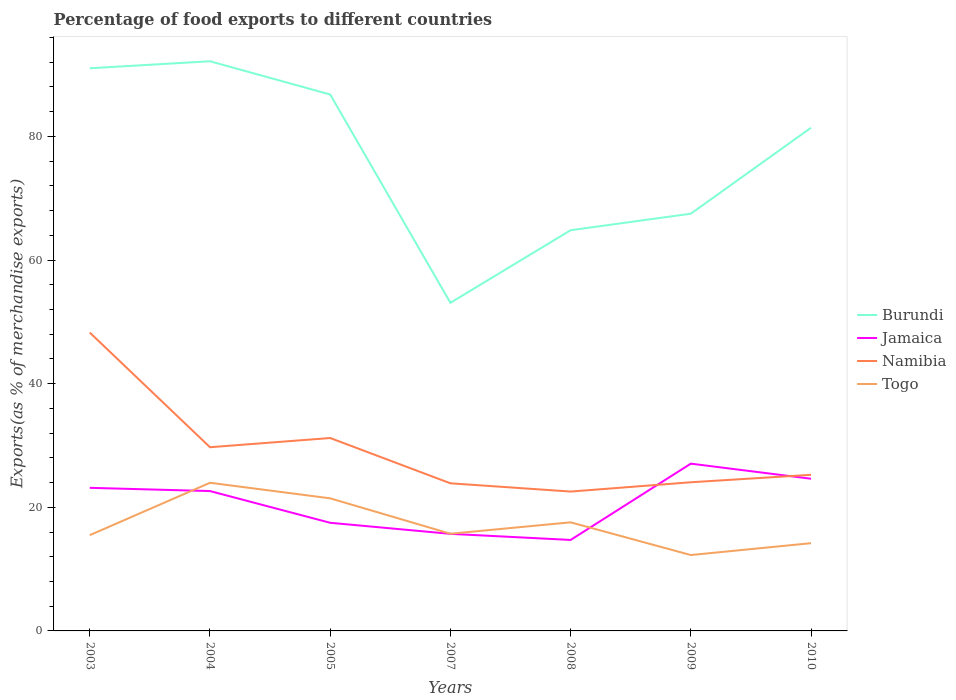How many different coloured lines are there?
Provide a short and direct response. 4. Across all years, what is the maximum percentage of exports to different countries in Namibia?
Offer a very short reply. 22.55. In which year was the percentage of exports to different countries in Togo maximum?
Ensure brevity in your answer.  2009. What is the total percentage of exports to different countries in Jamaica in the graph?
Provide a succinct answer. 5.13. What is the difference between the highest and the second highest percentage of exports to different countries in Jamaica?
Provide a short and direct response. 12.34. Is the percentage of exports to different countries in Jamaica strictly greater than the percentage of exports to different countries in Burundi over the years?
Give a very brief answer. Yes. How many lines are there?
Your response must be concise. 4. How many years are there in the graph?
Keep it short and to the point. 7. Are the values on the major ticks of Y-axis written in scientific E-notation?
Keep it short and to the point. No. Does the graph contain grids?
Offer a terse response. No. What is the title of the graph?
Offer a very short reply. Percentage of food exports to different countries. What is the label or title of the Y-axis?
Your answer should be compact. Exports(as % of merchandise exports). What is the Exports(as % of merchandise exports) in Burundi in 2003?
Make the answer very short. 91.03. What is the Exports(as % of merchandise exports) of Jamaica in 2003?
Your response must be concise. 23.15. What is the Exports(as % of merchandise exports) of Namibia in 2003?
Provide a short and direct response. 48.27. What is the Exports(as % of merchandise exports) of Togo in 2003?
Ensure brevity in your answer.  15.49. What is the Exports(as % of merchandise exports) of Burundi in 2004?
Give a very brief answer. 92.16. What is the Exports(as % of merchandise exports) in Jamaica in 2004?
Provide a short and direct response. 22.63. What is the Exports(as % of merchandise exports) in Namibia in 2004?
Offer a terse response. 29.72. What is the Exports(as % of merchandise exports) in Togo in 2004?
Offer a very short reply. 23.97. What is the Exports(as % of merchandise exports) of Burundi in 2005?
Keep it short and to the point. 86.78. What is the Exports(as % of merchandise exports) in Jamaica in 2005?
Provide a short and direct response. 17.49. What is the Exports(as % of merchandise exports) in Namibia in 2005?
Provide a short and direct response. 31.21. What is the Exports(as % of merchandise exports) in Togo in 2005?
Ensure brevity in your answer.  21.45. What is the Exports(as % of merchandise exports) in Burundi in 2007?
Your answer should be very brief. 53.08. What is the Exports(as % of merchandise exports) in Jamaica in 2007?
Provide a succinct answer. 15.7. What is the Exports(as % of merchandise exports) of Namibia in 2007?
Offer a very short reply. 23.88. What is the Exports(as % of merchandise exports) in Togo in 2007?
Offer a terse response. 15.72. What is the Exports(as % of merchandise exports) of Burundi in 2008?
Offer a very short reply. 64.83. What is the Exports(as % of merchandise exports) of Jamaica in 2008?
Provide a short and direct response. 14.72. What is the Exports(as % of merchandise exports) in Namibia in 2008?
Your answer should be very brief. 22.55. What is the Exports(as % of merchandise exports) of Togo in 2008?
Provide a succinct answer. 17.57. What is the Exports(as % of merchandise exports) of Burundi in 2009?
Your answer should be very brief. 67.5. What is the Exports(as % of merchandise exports) of Jamaica in 2009?
Ensure brevity in your answer.  27.06. What is the Exports(as % of merchandise exports) in Namibia in 2009?
Your answer should be compact. 24.05. What is the Exports(as % of merchandise exports) in Togo in 2009?
Make the answer very short. 12.28. What is the Exports(as % of merchandise exports) of Burundi in 2010?
Provide a succinct answer. 81.41. What is the Exports(as % of merchandise exports) of Jamaica in 2010?
Your answer should be compact. 24.62. What is the Exports(as % of merchandise exports) of Namibia in 2010?
Ensure brevity in your answer.  25.25. What is the Exports(as % of merchandise exports) in Togo in 2010?
Give a very brief answer. 14.2. Across all years, what is the maximum Exports(as % of merchandise exports) in Burundi?
Your answer should be compact. 92.16. Across all years, what is the maximum Exports(as % of merchandise exports) in Jamaica?
Give a very brief answer. 27.06. Across all years, what is the maximum Exports(as % of merchandise exports) in Namibia?
Make the answer very short. 48.27. Across all years, what is the maximum Exports(as % of merchandise exports) of Togo?
Give a very brief answer. 23.97. Across all years, what is the minimum Exports(as % of merchandise exports) in Burundi?
Offer a terse response. 53.08. Across all years, what is the minimum Exports(as % of merchandise exports) in Jamaica?
Offer a terse response. 14.72. Across all years, what is the minimum Exports(as % of merchandise exports) of Namibia?
Ensure brevity in your answer.  22.55. Across all years, what is the minimum Exports(as % of merchandise exports) in Togo?
Keep it short and to the point. 12.28. What is the total Exports(as % of merchandise exports) of Burundi in the graph?
Make the answer very short. 536.78. What is the total Exports(as % of merchandise exports) of Jamaica in the graph?
Keep it short and to the point. 145.37. What is the total Exports(as % of merchandise exports) in Namibia in the graph?
Give a very brief answer. 204.93. What is the total Exports(as % of merchandise exports) in Togo in the graph?
Your answer should be compact. 120.68. What is the difference between the Exports(as % of merchandise exports) in Burundi in 2003 and that in 2004?
Offer a terse response. -1.13. What is the difference between the Exports(as % of merchandise exports) in Jamaica in 2003 and that in 2004?
Make the answer very short. 0.52. What is the difference between the Exports(as % of merchandise exports) in Namibia in 2003 and that in 2004?
Offer a very short reply. 18.55. What is the difference between the Exports(as % of merchandise exports) of Togo in 2003 and that in 2004?
Offer a terse response. -8.47. What is the difference between the Exports(as % of merchandise exports) in Burundi in 2003 and that in 2005?
Offer a terse response. 4.24. What is the difference between the Exports(as % of merchandise exports) of Jamaica in 2003 and that in 2005?
Your answer should be compact. 5.66. What is the difference between the Exports(as % of merchandise exports) in Namibia in 2003 and that in 2005?
Ensure brevity in your answer.  17.06. What is the difference between the Exports(as % of merchandise exports) of Togo in 2003 and that in 2005?
Keep it short and to the point. -5.96. What is the difference between the Exports(as % of merchandise exports) of Burundi in 2003 and that in 2007?
Offer a terse response. 37.94. What is the difference between the Exports(as % of merchandise exports) in Jamaica in 2003 and that in 2007?
Your answer should be compact. 7.44. What is the difference between the Exports(as % of merchandise exports) in Namibia in 2003 and that in 2007?
Your answer should be very brief. 24.38. What is the difference between the Exports(as % of merchandise exports) of Togo in 2003 and that in 2007?
Provide a succinct answer. -0.23. What is the difference between the Exports(as % of merchandise exports) in Burundi in 2003 and that in 2008?
Your answer should be compact. 26.2. What is the difference between the Exports(as % of merchandise exports) in Jamaica in 2003 and that in 2008?
Your answer should be very brief. 8.43. What is the difference between the Exports(as % of merchandise exports) in Namibia in 2003 and that in 2008?
Your answer should be compact. 25.72. What is the difference between the Exports(as % of merchandise exports) of Togo in 2003 and that in 2008?
Make the answer very short. -2.07. What is the difference between the Exports(as % of merchandise exports) of Burundi in 2003 and that in 2009?
Offer a terse response. 23.53. What is the difference between the Exports(as % of merchandise exports) of Jamaica in 2003 and that in 2009?
Give a very brief answer. -3.91. What is the difference between the Exports(as % of merchandise exports) in Namibia in 2003 and that in 2009?
Offer a terse response. 24.22. What is the difference between the Exports(as % of merchandise exports) in Togo in 2003 and that in 2009?
Provide a short and direct response. 3.22. What is the difference between the Exports(as % of merchandise exports) in Burundi in 2003 and that in 2010?
Your answer should be compact. 9.62. What is the difference between the Exports(as % of merchandise exports) in Jamaica in 2003 and that in 2010?
Your answer should be compact. -1.47. What is the difference between the Exports(as % of merchandise exports) in Namibia in 2003 and that in 2010?
Make the answer very short. 23.01. What is the difference between the Exports(as % of merchandise exports) in Togo in 2003 and that in 2010?
Offer a terse response. 1.3. What is the difference between the Exports(as % of merchandise exports) of Burundi in 2004 and that in 2005?
Keep it short and to the point. 5.38. What is the difference between the Exports(as % of merchandise exports) in Jamaica in 2004 and that in 2005?
Your response must be concise. 5.13. What is the difference between the Exports(as % of merchandise exports) in Namibia in 2004 and that in 2005?
Provide a short and direct response. -1.49. What is the difference between the Exports(as % of merchandise exports) in Togo in 2004 and that in 2005?
Offer a very short reply. 2.52. What is the difference between the Exports(as % of merchandise exports) of Burundi in 2004 and that in 2007?
Offer a terse response. 39.08. What is the difference between the Exports(as % of merchandise exports) in Jamaica in 2004 and that in 2007?
Make the answer very short. 6.92. What is the difference between the Exports(as % of merchandise exports) in Namibia in 2004 and that in 2007?
Provide a short and direct response. 5.84. What is the difference between the Exports(as % of merchandise exports) in Togo in 2004 and that in 2007?
Your answer should be compact. 8.25. What is the difference between the Exports(as % of merchandise exports) in Burundi in 2004 and that in 2008?
Provide a succinct answer. 27.33. What is the difference between the Exports(as % of merchandise exports) in Jamaica in 2004 and that in 2008?
Your answer should be very brief. 7.91. What is the difference between the Exports(as % of merchandise exports) of Namibia in 2004 and that in 2008?
Offer a very short reply. 7.17. What is the difference between the Exports(as % of merchandise exports) of Togo in 2004 and that in 2008?
Provide a succinct answer. 6.4. What is the difference between the Exports(as % of merchandise exports) in Burundi in 2004 and that in 2009?
Offer a very short reply. 24.66. What is the difference between the Exports(as % of merchandise exports) in Jamaica in 2004 and that in 2009?
Provide a succinct answer. -4.44. What is the difference between the Exports(as % of merchandise exports) in Namibia in 2004 and that in 2009?
Offer a terse response. 5.67. What is the difference between the Exports(as % of merchandise exports) of Togo in 2004 and that in 2009?
Give a very brief answer. 11.69. What is the difference between the Exports(as % of merchandise exports) in Burundi in 2004 and that in 2010?
Your answer should be compact. 10.75. What is the difference between the Exports(as % of merchandise exports) in Jamaica in 2004 and that in 2010?
Offer a terse response. -1.99. What is the difference between the Exports(as % of merchandise exports) in Namibia in 2004 and that in 2010?
Keep it short and to the point. 4.46. What is the difference between the Exports(as % of merchandise exports) of Togo in 2004 and that in 2010?
Your answer should be compact. 9.77. What is the difference between the Exports(as % of merchandise exports) of Burundi in 2005 and that in 2007?
Give a very brief answer. 33.7. What is the difference between the Exports(as % of merchandise exports) of Jamaica in 2005 and that in 2007?
Offer a terse response. 1.79. What is the difference between the Exports(as % of merchandise exports) in Namibia in 2005 and that in 2007?
Offer a very short reply. 7.33. What is the difference between the Exports(as % of merchandise exports) in Togo in 2005 and that in 2007?
Offer a very short reply. 5.73. What is the difference between the Exports(as % of merchandise exports) of Burundi in 2005 and that in 2008?
Offer a terse response. 21.96. What is the difference between the Exports(as % of merchandise exports) in Jamaica in 2005 and that in 2008?
Your answer should be compact. 2.78. What is the difference between the Exports(as % of merchandise exports) of Namibia in 2005 and that in 2008?
Provide a succinct answer. 8.66. What is the difference between the Exports(as % of merchandise exports) in Togo in 2005 and that in 2008?
Give a very brief answer. 3.88. What is the difference between the Exports(as % of merchandise exports) of Burundi in 2005 and that in 2009?
Give a very brief answer. 19.28. What is the difference between the Exports(as % of merchandise exports) of Jamaica in 2005 and that in 2009?
Offer a very short reply. -9.57. What is the difference between the Exports(as % of merchandise exports) in Namibia in 2005 and that in 2009?
Keep it short and to the point. 7.16. What is the difference between the Exports(as % of merchandise exports) in Togo in 2005 and that in 2009?
Keep it short and to the point. 9.17. What is the difference between the Exports(as % of merchandise exports) of Burundi in 2005 and that in 2010?
Give a very brief answer. 5.38. What is the difference between the Exports(as % of merchandise exports) in Jamaica in 2005 and that in 2010?
Keep it short and to the point. -7.12. What is the difference between the Exports(as % of merchandise exports) in Namibia in 2005 and that in 2010?
Ensure brevity in your answer.  5.95. What is the difference between the Exports(as % of merchandise exports) of Togo in 2005 and that in 2010?
Ensure brevity in your answer.  7.25. What is the difference between the Exports(as % of merchandise exports) of Burundi in 2007 and that in 2008?
Give a very brief answer. -11.74. What is the difference between the Exports(as % of merchandise exports) of Jamaica in 2007 and that in 2008?
Provide a short and direct response. 0.99. What is the difference between the Exports(as % of merchandise exports) of Namibia in 2007 and that in 2008?
Ensure brevity in your answer.  1.34. What is the difference between the Exports(as % of merchandise exports) of Togo in 2007 and that in 2008?
Your answer should be very brief. -1.84. What is the difference between the Exports(as % of merchandise exports) in Burundi in 2007 and that in 2009?
Provide a succinct answer. -14.41. What is the difference between the Exports(as % of merchandise exports) in Jamaica in 2007 and that in 2009?
Your answer should be very brief. -11.36. What is the difference between the Exports(as % of merchandise exports) in Namibia in 2007 and that in 2009?
Your response must be concise. -0.17. What is the difference between the Exports(as % of merchandise exports) of Togo in 2007 and that in 2009?
Offer a terse response. 3.45. What is the difference between the Exports(as % of merchandise exports) of Burundi in 2007 and that in 2010?
Make the answer very short. -28.32. What is the difference between the Exports(as % of merchandise exports) in Jamaica in 2007 and that in 2010?
Offer a very short reply. -8.91. What is the difference between the Exports(as % of merchandise exports) of Namibia in 2007 and that in 2010?
Provide a succinct answer. -1.37. What is the difference between the Exports(as % of merchandise exports) in Togo in 2007 and that in 2010?
Your answer should be compact. 1.53. What is the difference between the Exports(as % of merchandise exports) in Burundi in 2008 and that in 2009?
Offer a very short reply. -2.67. What is the difference between the Exports(as % of merchandise exports) of Jamaica in 2008 and that in 2009?
Make the answer very short. -12.34. What is the difference between the Exports(as % of merchandise exports) of Namibia in 2008 and that in 2009?
Give a very brief answer. -1.5. What is the difference between the Exports(as % of merchandise exports) of Togo in 2008 and that in 2009?
Ensure brevity in your answer.  5.29. What is the difference between the Exports(as % of merchandise exports) in Burundi in 2008 and that in 2010?
Ensure brevity in your answer.  -16.58. What is the difference between the Exports(as % of merchandise exports) of Jamaica in 2008 and that in 2010?
Your answer should be very brief. -9.9. What is the difference between the Exports(as % of merchandise exports) in Namibia in 2008 and that in 2010?
Give a very brief answer. -2.71. What is the difference between the Exports(as % of merchandise exports) of Togo in 2008 and that in 2010?
Make the answer very short. 3.37. What is the difference between the Exports(as % of merchandise exports) in Burundi in 2009 and that in 2010?
Your answer should be very brief. -13.91. What is the difference between the Exports(as % of merchandise exports) of Jamaica in 2009 and that in 2010?
Your answer should be very brief. 2.44. What is the difference between the Exports(as % of merchandise exports) in Namibia in 2009 and that in 2010?
Your answer should be very brief. -1.2. What is the difference between the Exports(as % of merchandise exports) in Togo in 2009 and that in 2010?
Offer a terse response. -1.92. What is the difference between the Exports(as % of merchandise exports) in Burundi in 2003 and the Exports(as % of merchandise exports) in Jamaica in 2004?
Give a very brief answer. 68.4. What is the difference between the Exports(as % of merchandise exports) in Burundi in 2003 and the Exports(as % of merchandise exports) in Namibia in 2004?
Make the answer very short. 61.31. What is the difference between the Exports(as % of merchandise exports) of Burundi in 2003 and the Exports(as % of merchandise exports) of Togo in 2004?
Ensure brevity in your answer.  67.06. What is the difference between the Exports(as % of merchandise exports) of Jamaica in 2003 and the Exports(as % of merchandise exports) of Namibia in 2004?
Provide a succinct answer. -6.57. What is the difference between the Exports(as % of merchandise exports) of Jamaica in 2003 and the Exports(as % of merchandise exports) of Togo in 2004?
Ensure brevity in your answer.  -0.82. What is the difference between the Exports(as % of merchandise exports) of Namibia in 2003 and the Exports(as % of merchandise exports) of Togo in 2004?
Your answer should be compact. 24.3. What is the difference between the Exports(as % of merchandise exports) of Burundi in 2003 and the Exports(as % of merchandise exports) of Jamaica in 2005?
Your answer should be compact. 73.53. What is the difference between the Exports(as % of merchandise exports) of Burundi in 2003 and the Exports(as % of merchandise exports) of Namibia in 2005?
Your answer should be compact. 59.82. What is the difference between the Exports(as % of merchandise exports) of Burundi in 2003 and the Exports(as % of merchandise exports) of Togo in 2005?
Provide a succinct answer. 69.58. What is the difference between the Exports(as % of merchandise exports) of Jamaica in 2003 and the Exports(as % of merchandise exports) of Namibia in 2005?
Keep it short and to the point. -8.06. What is the difference between the Exports(as % of merchandise exports) of Jamaica in 2003 and the Exports(as % of merchandise exports) of Togo in 2005?
Offer a very short reply. 1.7. What is the difference between the Exports(as % of merchandise exports) of Namibia in 2003 and the Exports(as % of merchandise exports) of Togo in 2005?
Your response must be concise. 26.82. What is the difference between the Exports(as % of merchandise exports) in Burundi in 2003 and the Exports(as % of merchandise exports) in Jamaica in 2007?
Provide a short and direct response. 75.32. What is the difference between the Exports(as % of merchandise exports) in Burundi in 2003 and the Exports(as % of merchandise exports) in Namibia in 2007?
Your response must be concise. 67.14. What is the difference between the Exports(as % of merchandise exports) of Burundi in 2003 and the Exports(as % of merchandise exports) of Togo in 2007?
Keep it short and to the point. 75.3. What is the difference between the Exports(as % of merchandise exports) in Jamaica in 2003 and the Exports(as % of merchandise exports) in Namibia in 2007?
Offer a terse response. -0.73. What is the difference between the Exports(as % of merchandise exports) of Jamaica in 2003 and the Exports(as % of merchandise exports) of Togo in 2007?
Your answer should be very brief. 7.43. What is the difference between the Exports(as % of merchandise exports) of Namibia in 2003 and the Exports(as % of merchandise exports) of Togo in 2007?
Offer a very short reply. 32.54. What is the difference between the Exports(as % of merchandise exports) in Burundi in 2003 and the Exports(as % of merchandise exports) in Jamaica in 2008?
Provide a short and direct response. 76.31. What is the difference between the Exports(as % of merchandise exports) in Burundi in 2003 and the Exports(as % of merchandise exports) in Namibia in 2008?
Provide a succinct answer. 68.48. What is the difference between the Exports(as % of merchandise exports) in Burundi in 2003 and the Exports(as % of merchandise exports) in Togo in 2008?
Your answer should be very brief. 73.46. What is the difference between the Exports(as % of merchandise exports) of Jamaica in 2003 and the Exports(as % of merchandise exports) of Namibia in 2008?
Your answer should be very brief. 0.6. What is the difference between the Exports(as % of merchandise exports) of Jamaica in 2003 and the Exports(as % of merchandise exports) of Togo in 2008?
Keep it short and to the point. 5.58. What is the difference between the Exports(as % of merchandise exports) of Namibia in 2003 and the Exports(as % of merchandise exports) of Togo in 2008?
Make the answer very short. 30.7. What is the difference between the Exports(as % of merchandise exports) in Burundi in 2003 and the Exports(as % of merchandise exports) in Jamaica in 2009?
Your answer should be very brief. 63.96. What is the difference between the Exports(as % of merchandise exports) in Burundi in 2003 and the Exports(as % of merchandise exports) in Namibia in 2009?
Give a very brief answer. 66.98. What is the difference between the Exports(as % of merchandise exports) of Burundi in 2003 and the Exports(as % of merchandise exports) of Togo in 2009?
Make the answer very short. 78.75. What is the difference between the Exports(as % of merchandise exports) of Jamaica in 2003 and the Exports(as % of merchandise exports) of Namibia in 2009?
Your response must be concise. -0.9. What is the difference between the Exports(as % of merchandise exports) of Jamaica in 2003 and the Exports(as % of merchandise exports) of Togo in 2009?
Your answer should be compact. 10.87. What is the difference between the Exports(as % of merchandise exports) of Namibia in 2003 and the Exports(as % of merchandise exports) of Togo in 2009?
Your response must be concise. 35.99. What is the difference between the Exports(as % of merchandise exports) in Burundi in 2003 and the Exports(as % of merchandise exports) in Jamaica in 2010?
Ensure brevity in your answer.  66.41. What is the difference between the Exports(as % of merchandise exports) of Burundi in 2003 and the Exports(as % of merchandise exports) of Namibia in 2010?
Your answer should be very brief. 65.77. What is the difference between the Exports(as % of merchandise exports) of Burundi in 2003 and the Exports(as % of merchandise exports) of Togo in 2010?
Give a very brief answer. 76.83. What is the difference between the Exports(as % of merchandise exports) in Jamaica in 2003 and the Exports(as % of merchandise exports) in Namibia in 2010?
Give a very brief answer. -2.11. What is the difference between the Exports(as % of merchandise exports) of Jamaica in 2003 and the Exports(as % of merchandise exports) of Togo in 2010?
Your answer should be compact. 8.95. What is the difference between the Exports(as % of merchandise exports) in Namibia in 2003 and the Exports(as % of merchandise exports) in Togo in 2010?
Ensure brevity in your answer.  34.07. What is the difference between the Exports(as % of merchandise exports) of Burundi in 2004 and the Exports(as % of merchandise exports) of Jamaica in 2005?
Offer a very short reply. 74.67. What is the difference between the Exports(as % of merchandise exports) in Burundi in 2004 and the Exports(as % of merchandise exports) in Namibia in 2005?
Keep it short and to the point. 60.95. What is the difference between the Exports(as % of merchandise exports) in Burundi in 2004 and the Exports(as % of merchandise exports) in Togo in 2005?
Ensure brevity in your answer.  70.71. What is the difference between the Exports(as % of merchandise exports) of Jamaica in 2004 and the Exports(as % of merchandise exports) of Namibia in 2005?
Your answer should be compact. -8.58. What is the difference between the Exports(as % of merchandise exports) of Jamaica in 2004 and the Exports(as % of merchandise exports) of Togo in 2005?
Offer a terse response. 1.18. What is the difference between the Exports(as % of merchandise exports) in Namibia in 2004 and the Exports(as % of merchandise exports) in Togo in 2005?
Keep it short and to the point. 8.27. What is the difference between the Exports(as % of merchandise exports) in Burundi in 2004 and the Exports(as % of merchandise exports) in Jamaica in 2007?
Your response must be concise. 76.45. What is the difference between the Exports(as % of merchandise exports) in Burundi in 2004 and the Exports(as % of merchandise exports) in Namibia in 2007?
Ensure brevity in your answer.  68.28. What is the difference between the Exports(as % of merchandise exports) in Burundi in 2004 and the Exports(as % of merchandise exports) in Togo in 2007?
Provide a succinct answer. 76.44. What is the difference between the Exports(as % of merchandise exports) of Jamaica in 2004 and the Exports(as % of merchandise exports) of Namibia in 2007?
Your answer should be compact. -1.26. What is the difference between the Exports(as % of merchandise exports) of Jamaica in 2004 and the Exports(as % of merchandise exports) of Togo in 2007?
Offer a terse response. 6.9. What is the difference between the Exports(as % of merchandise exports) in Namibia in 2004 and the Exports(as % of merchandise exports) in Togo in 2007?
Keep it short and to the point. 14. What is the difference between the Exports(as % of merchandise exports) of Burundi in 2004 and the Exports(as % of merchandise exports) of Jamaica in 2008?
Give a very brief answer. 77.44. What is the difference between the Exports(as % of merchandise exports) in Burundi in 2004 and the Exports(as % of merchandise exports) in Namibia in 2008?
Provide a succinct answer. 69.61. What is the difference between the Exports(as % of merchandise exports) of Burundi in 2004 and the Exports(as % of merchandise exports) of Togo in 2008?
Your answer should be very brief. 74.59. What is the difference between the Exports(as % of merchandise exports) in Jamaica in 2004 and the Exports(as % of merchandise exports) in Namibia in 2008?
Your answer should be very brief. 0.08. What is the difference between the Exports(as % of merchandise exports) in Jamaica in 2004 and the Exports(as % of merchandise exports) in Togo in 2008?
Make the answer very short. 5.06. What is the difference between the Exports(as % of merchandise exports) in Namibia in 2004 and the Exports(as % of merchandise exports) in Togo in 2008?
Provide a short and direct response. 12.15. What is the difference between the Exports(as % of merchandise exports) of Burundi in 2004 and the Exports(as % of merchandise exports) of Jamaica in 2009?
Give a very brief answer. 65.1. What is the difference between the Exports(as % of merchandise exports) of Burundi in 2004 and the Exports(as % of merchandise exports) of Namibia in 2009?
Offer a very short reply. 68.11. What is the difference between the Exports(as % of merchandise exports) of Burundi in 2004 and the Exports(as % of merchandise exports) of Togo in 2009?
Your answer should be very brief. 79.88. What is the difference between the Exports(as % of merchandise exports) of Jamaica in 2004 and the Exports(as % of merchandise exports) of Namibia in 2009?
Give a very brief answer. -1.42. What is the difference between the Exports(as % of merchandise exports) of Jamaica in 2004 and the Exports(as % of merchandise exports) of Togo in 2009?
Your answer should be very brief. 10.35. What is the difference between the Exports(as % of merchandise exports) of Namibia in 2004 and the Exports(as % of merchandise exports) of Togo in 2009?
Provide a succinct answer. 17.44. What is the difference between the Exports(as % of merchandise exports) of Burundi in 2004 and the Exports(as % of merchandise exports) of Jamaica in 2010?
Your answer should be compact. 67.54. What is the difference between the Exports(as % of merchandise exports) in Burundi in 2004 and the Exports(as % of merchandise exports) in Namibia in 2010?
Make the answer very short. 66.91. What is the difference between the Exports(as % of merchandise exports) of Burundi in 2004 and the Exports(as % of merchandise exports) of Togo in 2010?
Your answer should be very brief. 77.96. What is the difference between the Exports(as % of merchandise exports) in Jamaica in 2004 and the Exports(as % of merchandise exports) in Namibia in 2010?
Offer a very short reply. -2.63. What is the difference between the Exports(as % of merchandise exports) of Jamaica in 2004 and the Exports(as % of merchandise exports) of Togo in 2010?
Your answer should be compact. 8.43. What is the difference between the Exports(as % of merchandise exports) of Namibia in 2004 and the Exports(as % of merchandise exports) of Togo in 2010?
Keep it short and to the point. 15.52. What is the difference between the Exports(as % of merchandise exports) of Burundi in 2005 and the Exports(as % of merchandise exports) of Jamaica in 2007?
Offer a terse response. 71.08. What is the difference between the Exports(as % of merchandise exports) of Burundi in 2005 and the Exports(as % of merchandise exports) of Namibia in 2007?
Keep it short and to the point. 62.9. What is the difference between the Exports(as % of merchandise exports) in Burundi in 2005 and the Exports(as % of merchandise exports) in Togo in 2007?
Offer a very short reply. 71.06. What is the difference between the Exports(as % of merchandise exports) of Jamaica in 2005 and the Exports(as % of merchandise exports) of Namibia in 2007?
Your answer should be compact. -6.39. What is the difference between the Exports(as % of merchandise exports) in Jamaica in 2005 and the Exports(as % of merchandise exports) in Togo in 2007?
Your answer should be very brief. 1.77. What is the difference between the Exports(as % of merchandise exports) of Namibia in 2005 and the Exports(as % of merchandise exports) of Togo in 2007?
Make the answer very short. 15.49. What is the difference between the Exports(as % of merchandise exports) of Burundi in 2005 and the Exports(as % of merchandise exports) of Jamaica in 2008?
Your response must be concise. 72.06. What is the difference between the Exports(as % of merchandise exports) of Burundi in 2005 and the Exports(as % of merchandise exports) of Namibia in 2008?
Make the answer very short. 64.24. What is the difference between the Exports(as % of merchandise exports) of Burundi in 2005 and the Exports(as % of merchandise exports) of Togo in 2008?
Your answer should be compact. 69.21. What is the difference between the Exports(as % of merchandise exports) in Jamaica in 2005 and the Exports(as % of merchandise exports) in Namibia in 2008?
Your response must be concise. -5.05. What is the difference between the Exports(as % of merchandise exports) of Jamaica in 2005 and the Exports(as % of merchandise exports) of Togo in 2008?
Your response must be concise. -0.07. What is the difference between the Exports(as % of merchandise exports) in Namibia in 2005 and the Exports(as % of merchandise exports) in Togo in 2008?
Your answer should be very brief. 13.64. What is the difference between the Exports(as % of merchandise exports) in Burundi in 2005 and the Exports(as % of merchandise exports) in Jamaica in 2009?
Make the answer very short. 59.72. What is the difference between the Exports(as % of merchandise exports) in Burundi in 2005 and the Exports(as % of merchandise exports) in Namibia in 2009?
Your response must be concise. 62.73. What is the difference between the Exports(as % of merchandise exports) in Burundi in 2005 and the Exports(as % of merchandise exports) in Togo in 2009?
Your answer should be very brief. 74.51. What is the difference between the Exports(as % of merchandise exports) in Jamaica in 2005 and the Exports(as % of merchandise exports) in Namibia in 2009?
Keep it short and to the point. -6.56. What is the difference between the Exports(as % of merchandise exports) in Jamaica in 2005 and the Exports(as % of merchandise exports) in Togo in 2009?
Your answer should be compact. 5.22. What is the difference between the Exports(as % of merchandise exports) in Namibia in 2005 and the Exports(as % of merchandise exports) in Togo in 2009?
Provide a short and direct response. 18.93. What is the difference between the Exports(as % of merchandise exports) of Burundi in 2005 and the Exports(as % of merchandise exports) of Jamaica in 2010?
Keep it short and to the point. 62.16. What is the difference between the Exports(as % of merchandise exports) of Burundi in 2005 and the Exports(as % of merchandise exports) of Namibia in 2010?
Provide a succinct answer. 61.53. What is the difference between the Exports(as % of merchandise exports) in Burundi in 2005 and the Exports(as % of merchandise exports) in Togo in 2010?
Provide a succinct answer. 72.59. What is the difference between the Exports(as % of merchandise exports) in Jamaica in 2005 and the Exports(as % of merchandise exports) in Namibia in 2010?
Make the answer very short. -7.76. What is the difference between the Exports(as % of merchandise exports) of Jamaica in 2005 and the Exports(as % of merchandise exports) of Togo in 2010?
Keep it short and to the point. 3.3. What is the difference between the Exports(as % of merchandise exports) in Namibia in 2005 and the Exports(as % of merchandise exports) in Togo in 2010?
Keep it short and to the point. 17.01. What is the difference between the Exports(as % of merchandise exports) of Burundi in 2007 and the Exports(as % of merchandise exports) of Jamaica in 2008?
Your answer should be very brief. 38.37. What is the difference between the Exports(as % of merchandise exports) in Burundi in 2007 and the Exports(as % of merchandise exports) in Namibia in 2008?
Your answer should be compact. 30.54. What is the difference between the Exports(as % of merchandise exports) in Burundi in 2007 and the Exports(as % of merchandise exports) in Togo in 2008?
Give a very brief answer. 35.52. What is the difference between the Exports(as % of merchandise exports) in Jamaica in 2007 and the Exports(as % of merchandise exports) in Namibia in 2008?
Offer a very short reply. -6.84. What is the difference between the Exports(as % of merchandise exports) of Jamaica in 2007 and the Exports(as % of merchandise exports) of Togo in 2008?
Your response must be concise. -1.86. What is the difference between the Exports(as % of merchandise exports) in Namibia in 2007 and the Exports(as % of merchandise exports) in Togo in 2008?
Keep it short and to the point. 6.31. What is the difference between the Exports(as % of merchandise exports) of Burundi in 2007 and the Exports(as % of merchandise exports) of Jamaica in 2009?
Your answer should be very brief. 26.02. What is the difference between the Exports(as % of merchandise exports) in Burundi in 2007 and the Exports(as % of merchandise exports) in Namibia in 2009?
Provide a succinct answer. 29.03. What is the difference between the Exports(as % of merchandise exports) of Burundi in 2007 and the Exports(as % of merchandise exports) of Togo in 2009?
Make the answer very short. 40.81. What is the difference between the Exports(as % of merchandise exports) of Jamaica in 2007 and the Exports(as % of merchandise exports) of Namibia in 2009?
Your response must be concise. -8.35. What is the difference between the Exports(as % of merchandise exports) in Jamaica in 2007 and the Exports(as % of merchandise exports) in Togo in 2009?
Give a very brief answer. 3.43. What is the difference between the Exports(as % of merchandise exports) in Namibia in 2007 and the Exports(as % of merchandise exports) in Togo in 2009?
Offer a terse response. 11.61. What is the difference between the Exports(as % of merchandise exports) in Burundi in 2007 and the Exports(as % of merchandise exports) in Jamaica in 2010?
Ensure brevity in your answer.  28.47. What is the difference between the Exports(as % of merchandise exports) of Burundi in 2007 and the Exports(as % of merchandise exports) of Namibia in 2010?
Give a very brief answer. 27.83. What is the difference between the Exports(as % of merchandise exports) in Burundi in 2007 and the Exports(as % of merchandise exports) in Togo in 2010?
Provide a succinct answer. 38.89. What is the difference between the Exports(as % of merchandise exports) in Jamaica in 2007 and the Exports(as % of merchandise exports) in Namibia in 2010?
Keep it short and to the point. -9.55. What is the difference between the Exports(as % of merchandise exports) in Jamaica in 2007 and the Exports(as % of merchandise exports) in Togo in 2010?
Offer a very short reply. 1.51. What is the difference between the Exports(as % of merchandise exports) in Namibia in 2007 and the Exports(as % of merchandise exports) in Togo in 2010?
Make the answer very short. 9.69. What is the difference between the Exports(as % of merchandise exports) in Burundi in 2008 and the Exports(as % of merchandise exports) in Jamaica in 2009?
Your answer should be compact. 37.76. What is the difference between the Exports(as % of merchandise exports) in Burundi in 2008 and the Exports(as % of merchandise exports) in Namibia in 2009?
Provide a succinct answer. 40.78. What is the difference between the Exports(as % of merchandise exports) of Burundi in 2008 and the Exports(as % of merchandise exports) of Togo in 2009?
Keep it short and to the point. 52.55. What is the difference between the Exports(as % of merchandise exports) of Jamaica in 2008 and the Exports(as % of merchandise exports) of Namibia in 2009?
Make the answer very short. -9.33. What is the difference between the Exports(as % of merchandise exports) of Jamaica in 2008 and the Exports(as % of merchandise exports) of Togo in 2009?
Offer a very short reply. 2.44. What is the difference between the Exports(as % of merchandise exports) in Namibia in 2008 and the Exports(as % of merchandise exports) in Togo in 2009?
Your response must be concise. 10.27. What is the difference between the Exports(as % of merchandise exports) of Burundi in 2008 and the Exports(as % of merchandise exports) of Jamaica in 2010?
Give a very brief answer. 40.21. What is the difference between the Exports(as % of merchandise exports) in Burundi in 2008 and the Exports(as % of merchandise exports) in Namibia in 2010?
Keep it short and to the point. 39.57. What is the difference between the Exports(as % of merchandise exports) of Burundi in 2008 and the Exports(as % of merchandise exports) of Togo in 2010?
Give a very brief answer. 50.63. What is the difference between the Exports(as % of merchandise exports) of Jamaica in 2008 and the Exports(as % of merchandise exports) of Namibia in 2010?
Offer a terse response. -10.54. What is the difference between the Exports(as % of merchandise exports) of Jamaica in 2008 and the Exports(as % of merchandise exports) of Togo in 2010?
Offer a terse response. 0.52. What is the difference between the Exports(as % of merchandise exports) of Namibia in 2008 and the Exports(as % of merchandise exports) of Togo in 2010?
Provide a succinct answer. 8.35. What is the difference between the Exports(as % of merchandise exports) of Burundi in 2009 and the Exports(as % of merchandise exports) of Jamaica in 2010?
Keep it short and to the point. 42.88. What is the difference between the Exports(as % of merchandise exports) in Burundi in 2009 and the Exports(as % of merchandise exports) in Namibia in 2010?
Your response must be concise. 42.24. What is the difference between the Exports(as % of merchandise exports) of Burundi in 2009 and the Exports(as % of merchandise exports) of Togo in 2010?
Your answer should be very brief. 53.3. What is the difference between the Exports(as % of merchandise exports) of Jamaica in 2009 and the Exports(as % of merchandise exports) of Namibia in 2010?
Your response must be concise. 1.81. What is the difference between the Exports(as % of merchandise exports) in Jamaica in 2009 and the Exports(as % of merchandise exports) in Togo in 2010?
Offer a terse response. 12.87. What is the difference between the Exports(as % of merchandise exports) of Namibia in 2009 and the Exports(as % of merchandise exports) of Togo in 2010?
Your answer should be very brief. 9.85. What is the average Exports(as % of merchandise exports) in Burundi per year?
Provide a short and direct response. 76.68. What is the average Exports(as % of merchandise exports) of Jamaica per year?
Your answer should be compact. 20.77. What is the average Exports(as % of merchandise exports) in Namibia per year?
Your response must be concise. 29.28. What is the average Exports(as % of merchandise exports) in Togo per year?
Keep it short and to the point. 17.24. In the year 2003, what is the difference between the Exports(as % of merchandise exports) in Burundi and Exports(as % of merchandise exports) in Jamaica?
Offer a very short reply. 67.88. In the year 2003, what is the difference between the Exports(as % of merchandise exports) in Burundi and Exports(as % of merchandise exports) in Namibia?
Give a very brief answer. 42.76. In the year 2003, what is the difference between the Exports(as % of merchandise exports) of Burundi and Exports(as % of merchandise exports) of Togo?
Your response must be concise. 75.53. In the year 2003, what is the difference between the Exports(as % of merchandise exports) in Jamaica and Exports(as % of merchandise exports) in Namibia?
Ensure brevity in your answer.  -25.12. In the year 2003, what is the difference between the Exports(as % of merchandise exports) in Jamaica and Exports(as % of merchandise exports) in Togo?
Offer a very short reply. 7.65. In the year 2003, what is the difference between the Exports(as % of merchandise exports) in Namibia and Exports(as % of merchandise exports) in Togo?
Your answer should be compact. 32.77. In the year 2004, what is the difference between the Exports(as % of merchandise exports) of Burundi and Exports(as % of merchandise exports) of Jamaica?
Provide a short and direct response. 69.53. In the year 2004, what is the difference between the Exports(as % of merchandise exports) in Burundi and Exports(as % of merchandise exports) in Namibia?
Provide a succinct answer. 62.44. In the year 2004, what is the difference between the Exports(as % of merchandise exports) of Burundi and Exports(as % of merchandise exports) of Togo?
Your answer should be very brief. 68.19. In the year 2004, what is the difference between the Exports(as % of merchandise exports) of Jamaica and Exports(as % of merchandise exports) of Namibia?
Offer a terse response. -7.09. In the year 2004, what is the difference between the Exports(as % of merchandise exports) in Jamaica and Exports(as % of merchandise exports) in Togo?
Offer a terse response. -1.34. In the year 2004, what is the difference between the Exports(as % of merchandise exports) of Namibia and Exports(as % of merchandise exports) of Togo?
Offer a very short reply. 5.75. In the year 2005, what is the difference between the Exports(as % of merchandise exports) of Burundi and Exports(as % of merchandise exports) of Jamaica?
Provide a succinct answer. 69.29. In the year 2005, what is the difference between the Exports(as % of merchandise exports) in Burundi and Exports(as % of merchandise exports) in Namibia?
Your answer should be compact. 55.57. In the year 2005, what is the difference between the Exports(as % of merchandise exports) in Burundi and Exports(as % of merchandise exports) in Togo?
Provide a short and direct response. 65.33. In the year 2005, what is the difference between the Exports(as % of merchandise exports) of Jamaica and Exports(as % of merchandise exports) of Namibia?
Your response must be concise. -13.71. In the year 2005, what is the difference between the Exports(as % of merchandise exports) of Jamaica and Exports(as % of merchandise exports) of Togo?
Offer a very short reply. -3.96. In the year 2005, what is the difference between the Exports(as % of merchandise exports) in Namibia and Exports(as % of merchandise exports) in Togo?
Your answer should be very brief. 9.76. In the year 2007, what is the difference between the Exports(as % of merchandise exports) of Burundi and Exports(as % of merchandise exports) of Jamaica?
Provide a succinct answer. 37.38. In the year 2007, what is the difference between the Exports(as % of merchandise exports) of Burundi and Exports(as % of merchandise exports) of Namibia?
Give a very brief answer. 29.2. In the year 2007, what is the difference between the Exports(as % of merchandise exports) of Burundi and Exports(as % of merchandise exports) of Togo?
Offer a terse response. 37.36. In the year 2007, what is the difference between the Exports(as % of merchandise exports) in Jamaica and Exports(as % of merchandise exports) in Namibia?
Keep it short and to the point. -8.18. In the year 2007, what is the difference between the Exports(as % of merchandise exports) in Jamaica and Exports(as % of merchandise exports) in Togo?
Give a very brief answer. -0.02. In the year 2007, what is the difference between the Exports(as % of merchandise exports) of Namibia and Exports(as % of merchandise exports) of Togo?
Your response must be concise. 8.16. In the year 2008, what is the difference between the Exports(as % of merchandise exports) in Burundi and Exports(as % of merchandise exports) in Jamaica?
Ensure brevity in your answer.  50.11. In the year 2008, what is the difference between the Exports(as % of merchandise exports) of Burundi and Exports(as % of merchandise exports) of Namibia?
Make the answer very short. 42.28. In the year 2008, what is the difference between the Exports(as % of merchandise exports) of Burundi and Exports(as % of merchandise exports) of Togo?
Make the answer very short. 47.26. In the year 2008, what is the difference between the Exports(as % of merchandise exports) of Jamaica and Exports(as % of merchandise exports) of Namibia?
Provide a succinct answer. -7.83. In the year 2008, what is the difference between the Exports(as % of merchandise exports) in Jamaica and Exports(as % of merchandise exports) in Togo?
Give a very brief answer. -2.85. In the year 2008, what is the difference between the Exports(as % of merchandise exports) in Namibia and Exports(as % of merchandise exports) in Togo?
Keep it short and to the point. 4.98. In the year 2009, what is the difference between the Exports(as % of merchandise exports) in Burundi and Exports(as % of merchandise exports) in Jamaica?
Your answer should be compact. 40.44. In the year 2009, what is the difference between the Exports(as % of merchandise exports) in Burundi and Exports(as % of merchandise exports) in Namibia?
Your answer should be very brief. 43.45. In the year 2009, what is the difference between the Exports(as % of merchandise exports) in Burundi and Exports(as % of merchandise exports) in Togo?
Provide a short and direct response. 55.22. In the year 2009, what is the difference between the Exports(as % of merchandise exports) in Jamaica and Exports(as % of merchandise exports) in Namibia?
Ensure brevity in your answer.  3.01. In the year 2009, what is the difference between the Exports(as % of merchandise exports) in Jamaica and Exports(as % of merchandise exports) in Togo?
Provide a short and direct response. 14.79. In the year 2009, what is the difference between the Exports(as % of merchandise exports) in Namibia and Exports(as % of merchandise exports) in Togo?
Offer a very short reply. 11.77. In the year 2010, what is the difference between the Exports(as % of merchandise exports) of Burundi and Exports(as % of merchandise exports) of Jamaica?
Offer a terse response. 56.79. In the year 2010, what is the difference between the Exports(as % of merchandise exports) in Burundi and Exports(as % of merchandise exports) in Namibia?
Make the answer very short. 56.15. In the year 2010, what is the difference between the Exports(as % of merchandise exports) of Burundi and Exports(as % of merchandise exports) of Togo?
Your answer should be very brief. 67.21. In the year 2010, what is the difference between the Exports(as % of merchandise exports) of Jamaica and Exports(as % of merchandise exports) of Namibia?
Provide a short and direct response. -0.64. In the year 2010, what is the difference between the Exports(as % of merchandise exports) in Jamaica and Exports(as % of merchandise exports) in Togo?
Your answer should be very brief. 10.42. In the year 2010, what is the difference between the Exports(as % of merchandise exports) in Namibia and Exports(as % of merchandise exports) in Togo?
Offer a very short reply. 11.06. What is the ratio of the Exports(as % of merchandise exports) in Burundi in 2003 to that in 2004?
Make the answer very short. 0.99. What is the ratio of the Exports(as % of merchandise exports) of Jamaica in 2003 to that in 2004?
Your answer should be compact. 1.02. What is the ratio of the Exports(as % of merchandise exports) of Namibia in 2003 to that in 2004?
Give a very brief answer. 1.62. What is the ratio of the Exports(as % of merchandise exports) in Togo in 2003 to that in 2004?
Ensure brevity in your answer.  0.65. What is the ratio of the Exports(as % of merchandise exports) in Burundi in 2003 to that in 2005?
Offer a terse response. 1.05. What is the ratio of the Exports(as % of merchandise exports) in Jamaica in 2003 to that in 2005?
Offer a very short reply. 1.32. What is the ratio of the Exports(as % of merchandise exports) in Namibia in 2003 to that in 2005?
Ensure brevity in your answer.  1.55. What is the ratio of the Exports(as % of merchandise exports) in Togo in 2003 to that in 2005?
Provide a succinct answer. 0.72. What is the ratio of the Exports(as % of merchandise exports) in Burundi in 2003 to that in 2007?
Keep it short and to the point. 1.71. What is the ratio of the Exports(as % of merchandise exports) of Jamaica in 2003 to that in 2007?
Make the answer very short. 1.47. What is the ratio of the Exports(as % of merchandise exports) in Namibia in 2003 to that in 2007?
Give a very brief answer. 2.02. What is the ratio of the Exports(as % of merchandise exports) in Togo in 2003 to that in 2007?
Give a very brief answer. 0.99. What is the ratio of the Exports(as % of merchandise exports) of Burundi in 2003 to that in 2008?
Give a very brief answer. 1.4. What is the ratio of the Exports(as % of merchandise exports) in Jamaica in 2003 to that in 2008?
Offer a very short reply. 1.57. What is the ratio of the Exports(as % of merchandise exports) in Namibia in 2003 to that in 2008?
Make the answer very short. 2.14. What is the ratio of the Exports(as % of merchandise exports) of Togo in 2003 to that in 2008?
Your answer should be very brief. 0.88. What is the ratio of the Exports(as % of merchandise exports) of Burundi in 2003 to that in 2009?
Your answer should be very brief. 1.35. What is the ratio of the Exports(as % of merchandise exports) in Jamaica in 2003 to that in 2009?
Your response must be concise. 0.86. What is the ratio of the Exports(as % of merchandise exports) of Namibia in 2003 to that in 2009?
Offer a terse response. 2.01. What is the ratio of the Exports(as % of merchandise exports) of Togo in 2003 to that in 2009?
Your answer should be very brief. 1.26. What is the ratio of the Exports(as % of merchandise exports) of Burundi in 2003 to that in 2010?
Your answer should be compact. 1.12. What is the ratio of the Exports(as % of merchandise exports) in Jamaica in 2003 to that in 2010?
Your answer should be very brief. 0.94. What is the ratio of the Exports(as % of merchandise exports) of Namibia in 2003 to that in 2010?
Offer a terse response. 1.91. What is the ratio of the Exports(as % of merchandise exports) in Togo in 2003 to that in 2010?
Your response must be concise. 1.09. What is the ratio of the Exports(as % of merchandise exports) of Burundi in 2004 to that in 2005?
Your answer should be very brief. 1.06. What is the ratio of the Exports(as % of merchandise exports) in Jamaica in 2004 to that in 2005?
Provide a succinct answer. 1.29. What is the ratio of the Exports(as % of merchandise exports) of Namibia in 2004 to that in 2005?
Provide a succinct answer. 0.95. What is the ratio of the Exports(as % of merchandise exports) of Togo in 2004 to that in 2005?
Your answer should be very brief. 1.12. What is the ratio of the Exports(as % of merchandise exports) of Burundi in 2004 to that in 2007?
Provide a succinct answer. 1.74. What is the ratio of the Exports(as % of merchandise exports) of Jamaica in 2004 to that in 2007?
Provide a short and direct response. 1.44. What is the ratio of the Exports(as % of merchandise exports) in Namibia in 2004 to that in 2007?
Provide a succinct answer. 1.24. What is the ratio of the Exports(as % of merchandise exports) in Togo in 2004 to that in 2007?
Make the answer very short. 1.52. What is the ratio of the Exports(as % of merchandise exports) in Burundi in 2004 to that in 2008?
Your answer should be very brief. 1.42. What is the ratio of the Exports(as % of merchandise exports) of Jamaica in 2004 to that in 2008?
Provide a short and direct response. 1.54. What is the ratio of the Exports(as % of merchandise exports) of Namibia in 2004 to that in 2008?
Keep it short and to the point. 1.32. What is the ratio of the Exports(as % of merchandise exports) in Togo in 2004 to that in 2008?
Your answer should be very brief. 1.36. What is the ratio of the Exports(as % of merchandise exports) of Burundi in 2004 to that in 2009?
Your answer should be very brief. 1.37. What is the ratio of the Exports(as % of merchandise exports) of Jamaica in 2004 to that in 2009?
Make the answer very short. 0.84. What is the ratio of the Exports(as % of merchandise exports) in Namibia in 2004 to that in 2009?
Ensure brevity in your answer.  1.24. What is the ratio of the Exports(as % of merchandise exports) in Togo in 2004 to that in 2009?
Keep it short and to the point. 1.95. What is the ratio of the Exports(as % of merchandise exports) of Burundi in 2004 to that in 2010?
Make the answer very short. 1.13. What is the ratio of the Exports(as % of merchandise exports) in Jamaica in 2004 to that in 2010?
Your answer should be very brief. 0.92. What is the ratio of the Exports(as % of merchandise exports) of Namibia in 2004 to that in 2010?
Your response must be concise. 1.18. What is the ratio of the Exports(as % of merchandise exports) of Togo in 2004 to that in 2010?
Your answer should be compact. 1.69. What is the ratio of the Exports(as % of merchandise exports) in Burundi in 2005 to that in 2007?
Provide a short and direct response. 1.63. What is the ratio of the Exports(as % of merchandise exports) of Jamaica in 2005 to that in 2007?
Offer a very short reply. 1.11. What is the ratio of the Exports(as % of merchandise exports) in Namibia in 2005 to that in 2007?
Offer a terse response. 1.31. What is the ratio of the Exports(as % of merchandise exports) of Togo in 2005 to that in 2007?
Offer a very short reply. 1.36. What is the ratio of the Exports(as % of merchandise exports) in Burundi in 2005 to that in 2008?
Your response must be concise. 1.34. What is the ratio of the Exports(as % of merchandise exports) in Jamaica in 2005 to that in 2008?
Ensure brevity in your answer.  1.19. What is the ratio of the Exports(as % of merchandise exports) in Namibia in 2005 to that in 2008?
Ensure brevity in your answer.  1.38. What is the ratio of the Exports(as % of merchandise exports) in Togo in 2005 to that in 2008?
Provide a succinct answer. 1.22. What is the ratio of the Exports(as % of merchandise exports) of Burundi in 2005 to that in 2009?
Provide a short and direct response. 1.29. What is the ratio of the Exports(as % of merchandise exports) of Jamaica in 2005 to that in 2009?
Your response must be concise. 0.65. What is the ratio of the Exports(as % of merchandise exports) in Namibia in 2005 to that in 2009?
Your response must be concise. 1.3. What is the ratio of the Exports(as % of merchandise exports) in Togo in 2005 to that in 2009?
Offer a very short reply. 1.75. What is the ratio of the Exports(as % of merchandise exports) of Burundi in 2005 to that in 2010?
Your response must be concise. 1.07. What is the ratio of the Exports(as % of merchandise exports) of Jamaica in 2005 to that in 2010?
Your response must be concise. 0.71. What is the ratio of the Exports(as % of merchandise exports) of Namibia in 2005 to that in 2010?
Make the answer very short. 1.24. What is the ratio of the Exports(as % of merchandise exports) in Togo in 2005 to that in 2010?
Keep it short and to the point. 1.51. What is the ratio of the Exports(as % of merchandise exports) of Burundi in 2007 to that in 2008?
Provide a short and direct response. 0.82. What is the ratio of the Exports(as % of merchandise exports) in Jamaica in 2007 to that in 2008?
Provide a short and direct response. 1.07. What is the ratio of the Exports(as % of merchandise exports) of Namibia in 2007 to that in 2008?
Offer a very short reply. 1.06. What is the ratio of the Exports(as % of merchandise exports) in Togo in 2007 to that in 2008?
Offer a very short reply. 0.9. What is the ratio of the Exports(as % of merchandise exports) of Burundi in 2007 to that in 2009?
Your response must be concise. 0.79. What is the ratio of the Exports(as % of merchandise exports) in Jamaica in 2007 to that in 2009?
Offer a terse response. 0.58. What is the ratio of the Exports(as % of merchandise exports) in Namibia in 2007 to that in 2009?
Your response must be concise. 0.99. What is the ratio of the Exports(as % of merchandise exports) of Togo in 2007 to that in 2009?
Ensure brevity in your answer.  1.28. What is the ratio of the Exports(as % of merchandise exports) of Burundi in 2007 to that in 2010?
Make the answer very short. 0.65. What is the ratio of the Exports(as % of merchandise exports) of Jamaica in 2007 to that in 2010?
Provide a succinct answer. 0.64. What is the ratio of the Exports(as % of merchandise exports) in Namibia in 2007 to that in 2010?
Offer a very short reply. 0.95. What is the ratio of the Exports(as % of merchandise exports) of Togo in 2007 to that in 2010?
Your response must be concise. 1.11. What is the ratio of the Exports(as % of merchandise exports) in Burundi in 2008 to that in 2009?
Ensure brevity in your answer.  0.96. What is the ratio of the Exports(as % of merchandise exports) in Jamaica in 2008 to that in 2009?
Keep it short and to the point. 0.54. What is the ratio of the Exports(as % of merchandise exports) in Namibia in 2008 to that in 2009?
Ensure brevity in your answer.  0.94. What is the ratio of the Exports(as % of merchandise exports) in Togo in 2008 to that in 2009?
Give a very brief answer. 1.43. What is the ratio of the Exports(as % of merchandise exports) of Burundi in 2008 to that in 2010?
Keep it short and to the point. 0.8. What is the ratio of the Exports(as % of merchandise exports) in Jamaica in 2008 to that in 2010?
Provide a succinct answer. 0.6. What is the ratio of the Exports(as % of merchandise exports) of Namibia in 2008 to that in 2010?
Offer a very short reply. 0.89. What is the ratio of the Exports(as % of merchandise exports) of Togo in 2008 to that in 2010?
Keep it short and to the point. 1.24. What is the ratio of the Exports(as % of merchandise exports) in Burundi in 2009 to that in 2010?
Ensure brevity in your answer.  0.83. What is the ratio of the Exports(as % of merchandise exports) of Jamaica in 2009 to that in 2010?
Your answer should be compact. 1.1. What is the ratio of the Exports(as % of merchandise exports) of Namibia in 2009 to that in 2010?
Your response must be concise. 0.95. What is the ratio of the Exports(as % of merchandise exports) of Togo in 2009 to that in 2010?
Your response must be concise. 0.86. What is the difference between the highest and the second highest Exports(as % of merchandise exports) of Burundi?
Your response must be concise. 1.13. What is the difference between the highest and the second highest Exports(as % of merchandise exports) of Jamaica?
Make the answer very short. 2.44. What is the difference between the highest and the second highest Exports(as % of merchandise exports) in Namibia?
Keep it short and to the point. 17.06. What is the difference between the highest and the second highest Exports(as % of merchandise exports) in Togo?
Your answer should be compact. 2.52. What is the difference between the highest and the lowest Exports(as % of merchandise exports) of Burundi?
Make the answer very short. 39.08. What is the difference between the highest and the lowest Exports(as % of merchandise exports) of Jamaica?
Your response must be concise. 12.34. What is the difference between the highest and the lowest Exports(as % of merchandise exports) of Namibia?
Make the answer very short. 25.72. What is the difference between the highest and the lowest Exports(as % of merchandise exports) of Togo?
Your answer should be very brief. 11.69. 